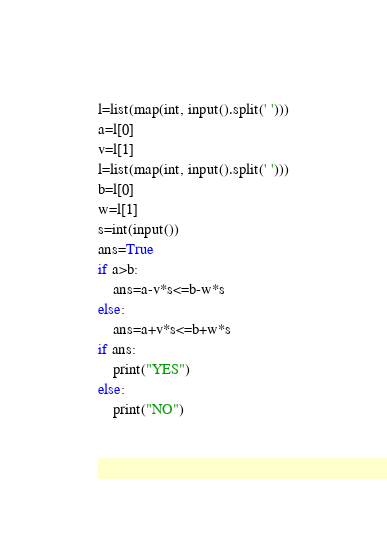<code> <loc_0><loc_0><loc_500><loc_500><_Python_>

l=list(map(int, input().split(' ')))
a=l[0]
v=l[1]
l=list(map(int, input().split(' ')))
b=l[0]
w=l[1]
s=int(input())
ans=True
if a>b:
    ans=a-v*s<=b-w*s
else:
    ans=a+v*s<=b+w*s
if ans:
    print("YES")
else:
    print("NO")
    

</code> 